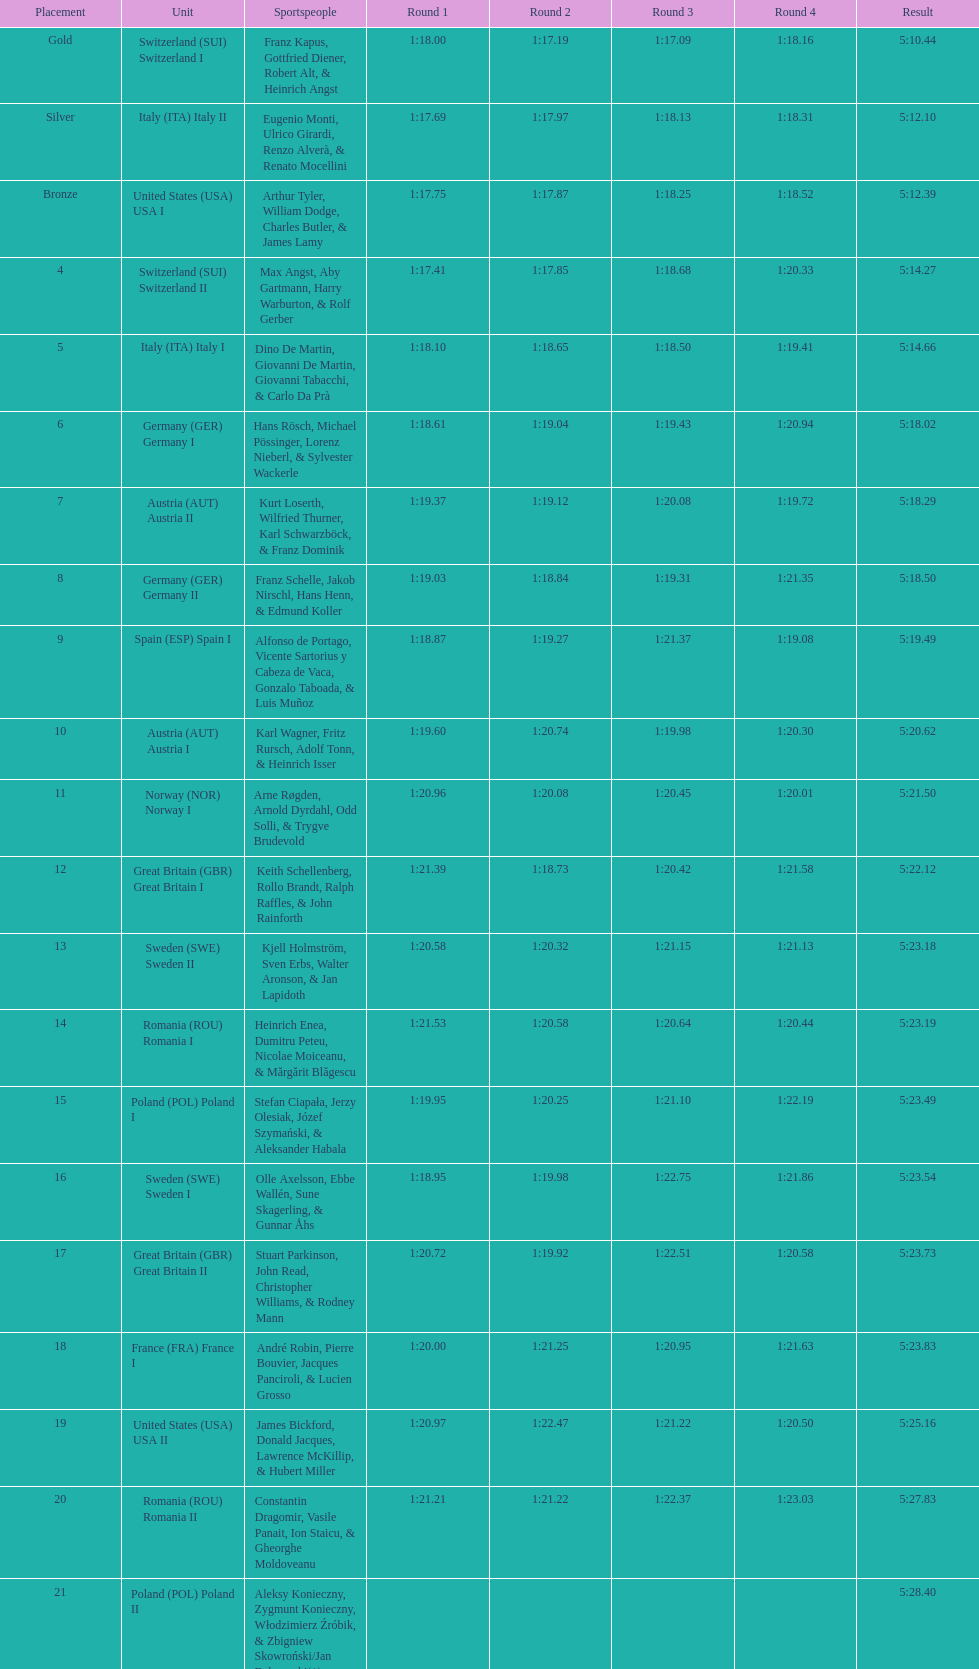Who placed the highest, italy or germany? Italy. 